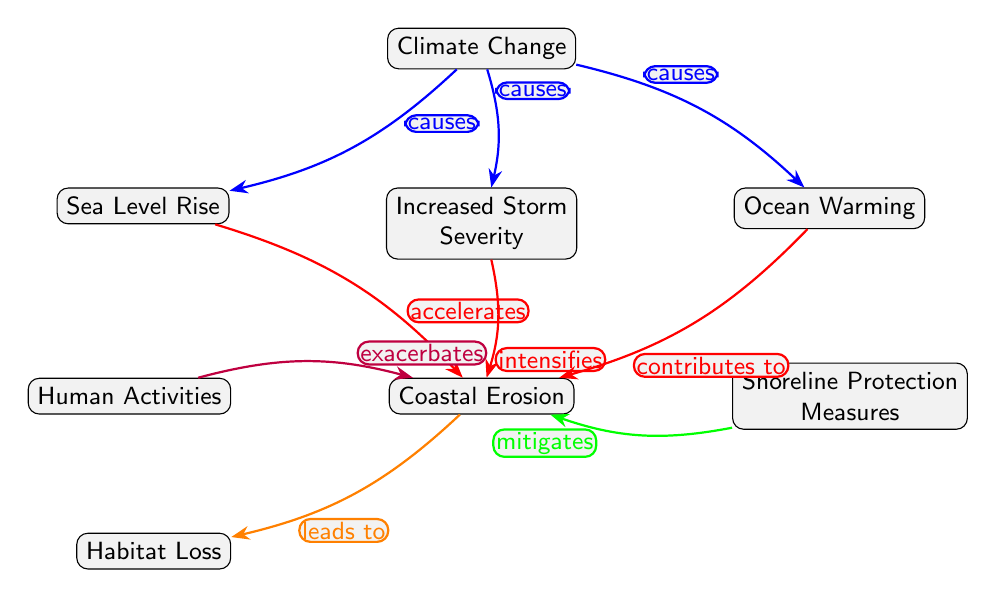What are the three main causes of climate change in the diagram? The diagram lists three causes connected to the "Climate Change" node: "Sea Level Rise," "Increased Storm Severity," and "Ocean Warming." These are directly connected to climate change with arrows labeled as "causes."
Answer: Sea Level Rise, Increased Storm Severity, Ocean Warming How many edges are there that connect to the "Coastal Erosion" node? Counting the edges leading into the "Coastal Erosion" node in the diagram, we see three contributing factors: "Sea Level Rise," "Increased Storm Severity," and "Ocean Warming," plus one from "Human Activities," and one from "Shoreline Protection." This totals five edges.
Answer: 5 What effect do "Human Activities" have on "Coastal Erosion"? In the diagram, the connection from "Human Activities" to "Coastal Erosion" is labeled "exacerbates," indicating that human activities worsen coastal erosion.
Answer: exacerbates What is the relationship between "Ocean Warming" and "Coastal Erosion"? The "Ocean Warming" node has an edge connecting it to "Coastal Erosion," labeled "contributes to," indicating that ocean warming helps to cause or accelerate coastal erosion.
Answer: contributes to Which factor leads to "Habitat Loss"? According to the diagram, "Coastal Erosion" is connected to "Habitat Loss" with an edge labeled "leads to," indicating habitat loss is a consequence of coastal erosion.
Answer: leads to What measures can mitigate "Coastal Erosion"? The edge connecting "Shoreline Protection Measures" to "Coastal Erosion" in the diagram is labeled "mitigates," indicating that these measures can help reduce the impact of coastal erosion.
Answer: mitigates How does "Increased Storm Severity" impact "Coastal Erosion"? The diagram shows an edge from "Increased Storm Severity" to "Coastal Erosion" with the label "intensifies," meaning that increased storm severity makes coastal erosion worse.
Answer: intensifies What role does "Sea Level Rise" play in "Coastal Erosion"? The relationship shown in the diagram indicates that "Sea Level Rise" "accelerates" "Coastal Erosion," meaning that as sea levels rise, coastal erosion speeds up.
Answer: accelerates 